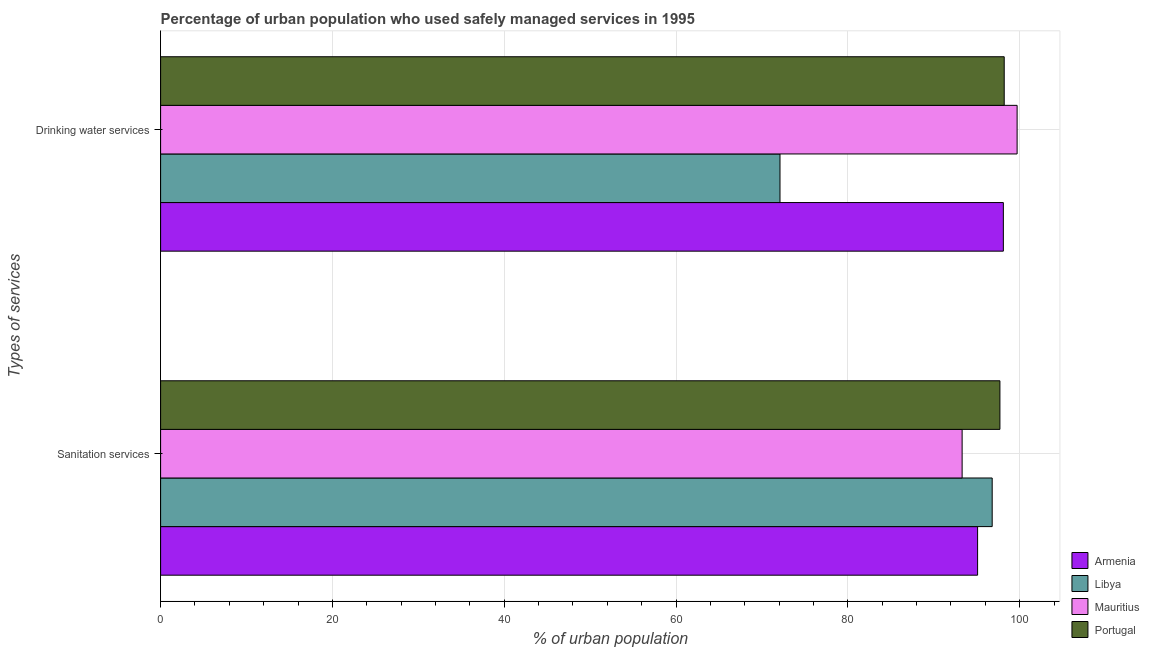How many groups of bars are there?
Offer a terse response. 2. Are the number of bars per tick equal to the number of legend labels?
Make the answer very short. Yes. Are the number of bars on each tick of the Y-axis equal?
Ensure brevity in your answer.  Yes. How many bars are there on the 2nd tick from the top?
Your answer should be compact. 4. How many bars are there on the 2nd tick from the bottom?
Keep it short and to the point. 4. What is the label of the 2nd group of bars from the top?
Give a very brief answer. Sanitation services. What is the percentage of urban population who used drinking water services in Libya?
Provide a succinct answer. 72.1. Across all countries, what is the maximum percentage of urban population who used sanitation services?
Keep it short and to the point. 97.7. Across all countries, what is the minimum percentage of urban population who used drinking water services?
Provide a short and direct response. 72.1. In which country was the percentage of urban population who used sanitation services maximum?
Your response must be concise. Portugal. In which country was the percentage of urban population who used sanitation services minimum?
Offer a very short reply. Mauritius. What is the total percentage of urban population who used drinking water services in the graph?
Make the answer very short. 368.1. What is the difference between the percentage of urban population who used sanitation services in Armenia and that in Mauritius?
Provide a short and direct response. 1.8. What is the difference between the percentage of urban population who used sanitation services in Armenia and the percentage of urban population who used drinking water services in Portugal?
Make the answer very short. -3.1. What is the average percentage of urban population who used drinking water services per country?
Provide a succinct answer. 92.02. What is the difference between the percentage of urban population who used sanitation services and percentage of urban population who used drinking water services in Mauritius?
Offer a terse response. -6.4. In how many countries, is the percentage of urban population who used sanitation services greater than 40 %?
Make the answer very short. 4. What is the ratio of the percentage of urban population who used sanitation services in Portugal to that in Mauritius?
Offer a very short reply. 1.05. Is the percentage of urban population who used sanitation services in Armenia less than that in Mauritius?
Keep it short and to the point. No. What does the 2nd bar from the top in Sanitation services represents?
Provide a succinct answer. Mauritius. What does the 4th bar from the bottom in Drinking water services represents?
Offer a terse response. Portugal. How many bars are there?
Provide a succinct answer. 8. Are all the bars in the graph horizontal?
Keep it short and to the point. Yes. What is the difference between two consecutive major ticks on the X-axis?
Provide a succinct answer. 20. Are the values on the major ticks of X-axis written in scientific E-notation?
Provide a succinct answer. No. Does the graph contain any zero values?
Offer a very short reply. No. How are the legend labels stacked?
Provide a short and direct response. Vertical. What is the title of the graph?
Provide a succinct answer. Percentage of urban population who used safely managed services in 1995. What is the label or title of the X-axis?
Your response must be concise. % of urban population. What is the label or title of the Y-axis?
Your answer should be very brief. Types of services. What is the % of urban population of Armenia in Sanitation services?
Your response must be concise. 95.1. What is the % of urban population in Libya in Sanitation services?
Offer a terse response. 96.8. What is the % of urban population in Mauritius in Sanitation services?
Your answer should be very brief. 93.3. What is the % of urban population in Portugal in Sanitation services?
Make the answer very short. 97.7. What is the % of urban population in Armenia in Drinking water services?
Your answer should be very brief. 98.1. What is the % of urban population of Libya in Drinking water services?
Ensure brevity in your answer.  72.1. What is the % of urban population of Mauritius in Drinking water services?
Keep it short and to the point. 99.7. What is the % of urban population of Portugal in Drinking water services?
Your answer should be very brief. 98.2. Across all Types of services, what is the maximum % of urban population in Armenia?
Keep it short and to the point. 98.1. Across all Types of services, what is the maximum % of urban population in Libya?
Keep it short and to the point. 96.8. Across all Types of services, what is the maximum % of urban population of Mauritius?
Your response must be concise. 99.7. Across all Types of services, what is the maximum % of urban population of Portugal?
Give a very brief answer. 98.2. Across all Types of services, what is the minimum % of urban population in Armenia?
Keep it short and to the point. 95.1. Across all Types of services, what is the minimum % of urban population in Libya?
Your answer should be compact. 72.1. Across all Types of services, what is the minimum % of urban population in Mauritius?
Your answer should be compact. 93.3. Across all Types of services, what is the minimum % of urban population of Portugal?
Provide a short and direct response. 97.7. What is the total % of urban population of Armenia in the graph?
Your answer should be very brief. 193.2. What is the total % of urban population in Libya in the graph?
Make the answer very short. 168.9. What is the total % of urban population of Mauritius in the graph?
Make the answer very short. 193. What is the total % of urban population of Portugal in the graph?
Provide a short and direct response. 195.9. What is the difference between the % of urban population of Armenia in Sanitation services and that in Drinking water services?
Your answer should be compact. -3. What is the difference between the % of urban population of Libya in Sanitation services and that in Drinking water services?
Your answer should be very brief. 24.7. What is the difference between the % of urban population of Armenia in Sanitation services and the % of urban population of Libya in Drinking water services?
Keep it short and to the point. 23. What is the difference between the % of urban population in Armenia in Sanitation services and the % of urban population in Portugal in Drinking water services?
Offer a very short reply. -3.1. What is the difference between the % of urban population of Libya in Sanitation services and the % of urban population of Mauritius in Drinking water services?
Your answer should be very brief. -2.9. What is the difference between the % of urban population of Mauritius in Sanitation services and the % of urban population of Portugal in Drinking water services?
Offer a very short reply. -4.9. What is the average % of urban population in Armenia per Types of services?
Make the answer very short. 96.6. What is the average % of urban population of Libya per Types of services?
Provide a succinct answer. 84.45. What is the average % of urban population in Mauritius per Types of services?
Your answer should be very brief. 96.5. What is the average % of urban population in Portugal per Types of services?
Give a very brief answer. 97.95. What is the difference between the % of urban population of Armenia and % of urban population of Libya in Sanitation services?
Offer a very short reply. -1.7. What is the difference between the % of urban population of Armenia and % of urban population of Mauritius in Sanitation services?
Provide a succinct answer. 1.8. What is the difference between the % of urban population in Armenia and % of urban population in Portugal in Sanitation services?
Your answer should be compact. -2.6. What is the difference between the % of urban population of Libya and % of urban population of Mauritius in Sanitation services?
Your answer should be very brief. 3.5. What is the difference between the % of urban population in Mauritius and % of urban population in Portugal in Sanitation services?
Offer a very short reply. -4.4. What is the difference between the % of urban population of Armenia and % of urban population of Libya in Drinking water services?
Your answer should be very brief. 26. What is the difference between the % of urban population of Armenia and % of urban population of Mauritius in Drinking water services?
Your response must be concise. -1.6. What is the difference between the % of urban population of Armenia and % of urban population of Portugal in Drinking water services?
Your response must be concise. -0.1. What is the difference between the % of urban population in Libya and % of urban population in Mauritius in Drinking water services?
Offer a terse response. -27.6. What is the difference between the % of urban population in Libya and % of urban population in Portugal in Drinking water services?
Your answer should be very brief. -26.1. What is the difference between the % of urban population in Mauritius and % of urban population in Portugal in Drinking water services?
Offer a terse response. 1.5. What is the ratio of the % of urban population of Armenia in Sanitation services to that in Drinking water services?
Ensure brevity in your answer.  0.97. What is the ratio of the % of urban population of Libya in Sanitation services to that in Drinking water services?
Give a very brief answer. 1.34. What is the ratio of the % of urban population in Mauritius in Sanitation services to that in Drinking water services?
Keep it short and to the point. 0.94. What is the difference between the highest and the second highest % of urban population of Libya?
Your response must be concise. 24.7. What is the difference between the highest and the second highest % of urban population in Mauritius?
Offer a terse response. 6.4. What is the difference between the highest and the second highest % of urban population of Portugal?
Provide a succinct answer. 0.5. What is the difference between the highest and the lowest % of urban population in Libya?
Offer a terse response. 24.7. 